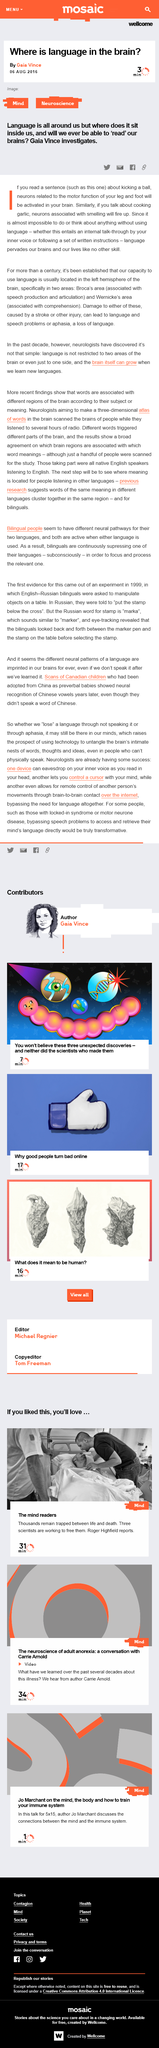Indicate a few pertinent items in this graphic. The article was written by Gaia Vince. The left hemisphere of the brain is commonly associated with language. Broca's Area and Wernicke's Area are the two areas of the brain that are associated with a person's capacity to use language. 